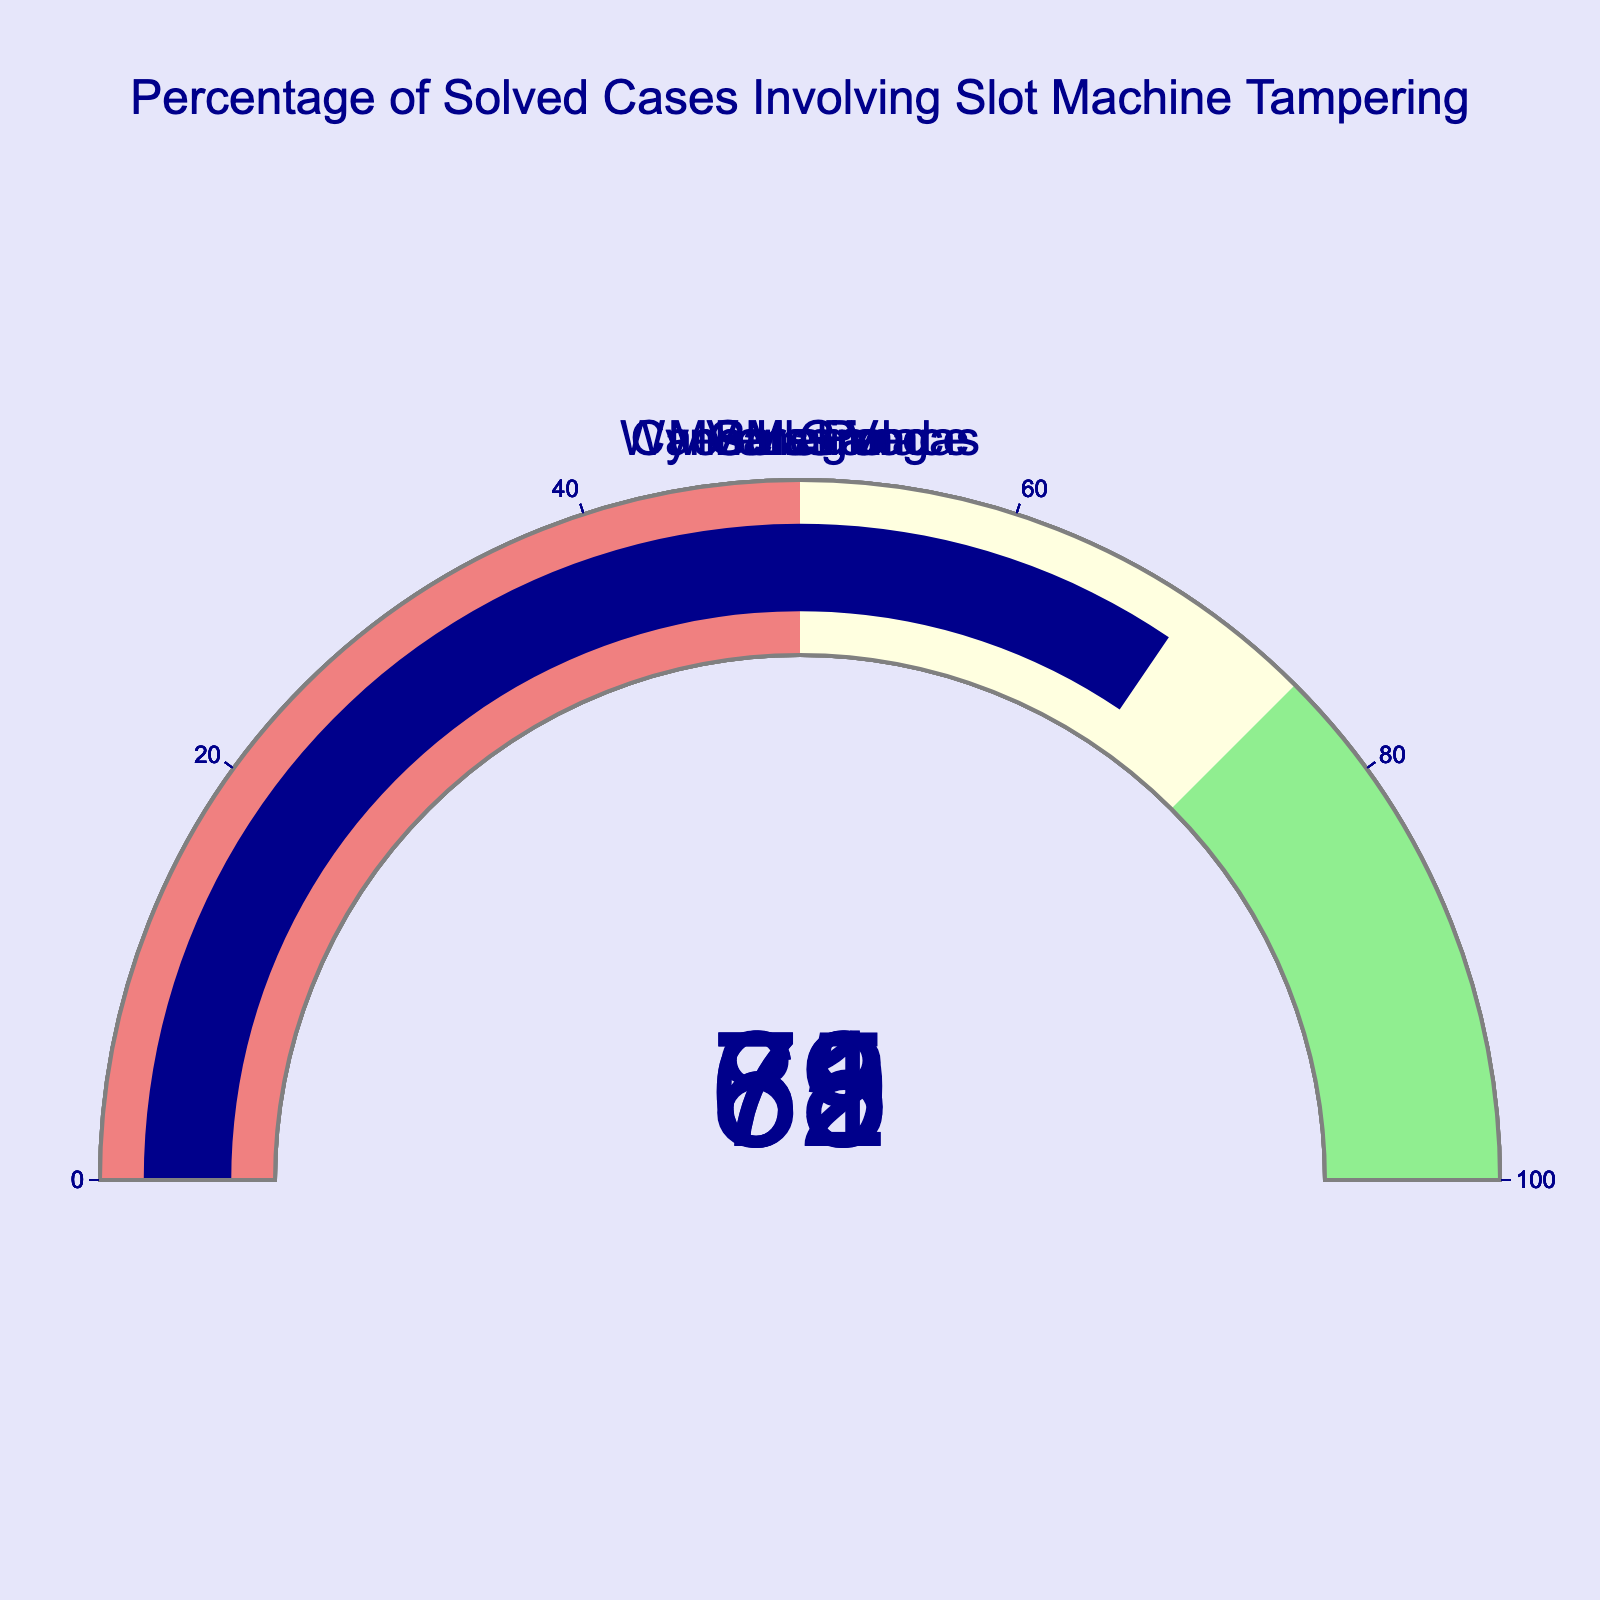What is the percentage of solved cases for Bellagio? The gauge chart for Bellagio shows a value of 78%, which represents the percentage of solved cases involving slot machine tampering for that casino.
Answer: 78% Which casino has the lowest percentage of solved cases? By looking at each gauge chart, we identify that MGM Grand has the lowest percentage, as its gauge shows 65%.
Answer: MGM Grand Which casino has the highest percentage of solved cases? Examining each gauge chart, we see that Caesars Palace has the highest percentage, with its gauge showing 82%.
Answer: Caesars Palace What is the median percentage of solved cases across the casinos? Arrange the percentages in ascending order: 65, 69, 71, 78, 82. The median is the middle number in this sequence, which is 71.
Answer: 71 How many casinos have a solved cases percentage greater than 70%? The casinos with solved cases percentages greater than 70% are Bellagio (78%), Caesars Palace (82%), and Wynn Las Vegas (71%). There are 3 casinos in total.
Answer: 3 How does the percentage for Venetian compare to the percentage for Wynn Las Vegas? The gauge chart shows Venetian with 69% and Wynn Las Vegas with 71%. Therefore, Venetian has a lower percentage than Wynn Las Vegas.
Answer: Venetian is lower If the average percentage of solved cases across these casinos was 75%, which casinos fall below this average? The casinos below the 75% average are MGM Grand (65%), Venetian (69%), and Wynn Las Vegas (71%).
Answer: MGM Grand, Venetian, Wynn Las Vegas What is the range of percentages of solved cases among the casinos? Calculate the difference between the highest percentage (82% at Caesars Palace) and the lowest percentage (65% at MGM Grand). The range is 82 - 65 = 17.
Answer: 17% Which color range does the Bellagio's solved cases percentage fall into? The color ranges are lightcoral (0-50), lightyellow (50-75), and lightgreen (75-100). Bellagio's percentage (78%) falls into the lightgreen range.
Answer: Lightgreen 